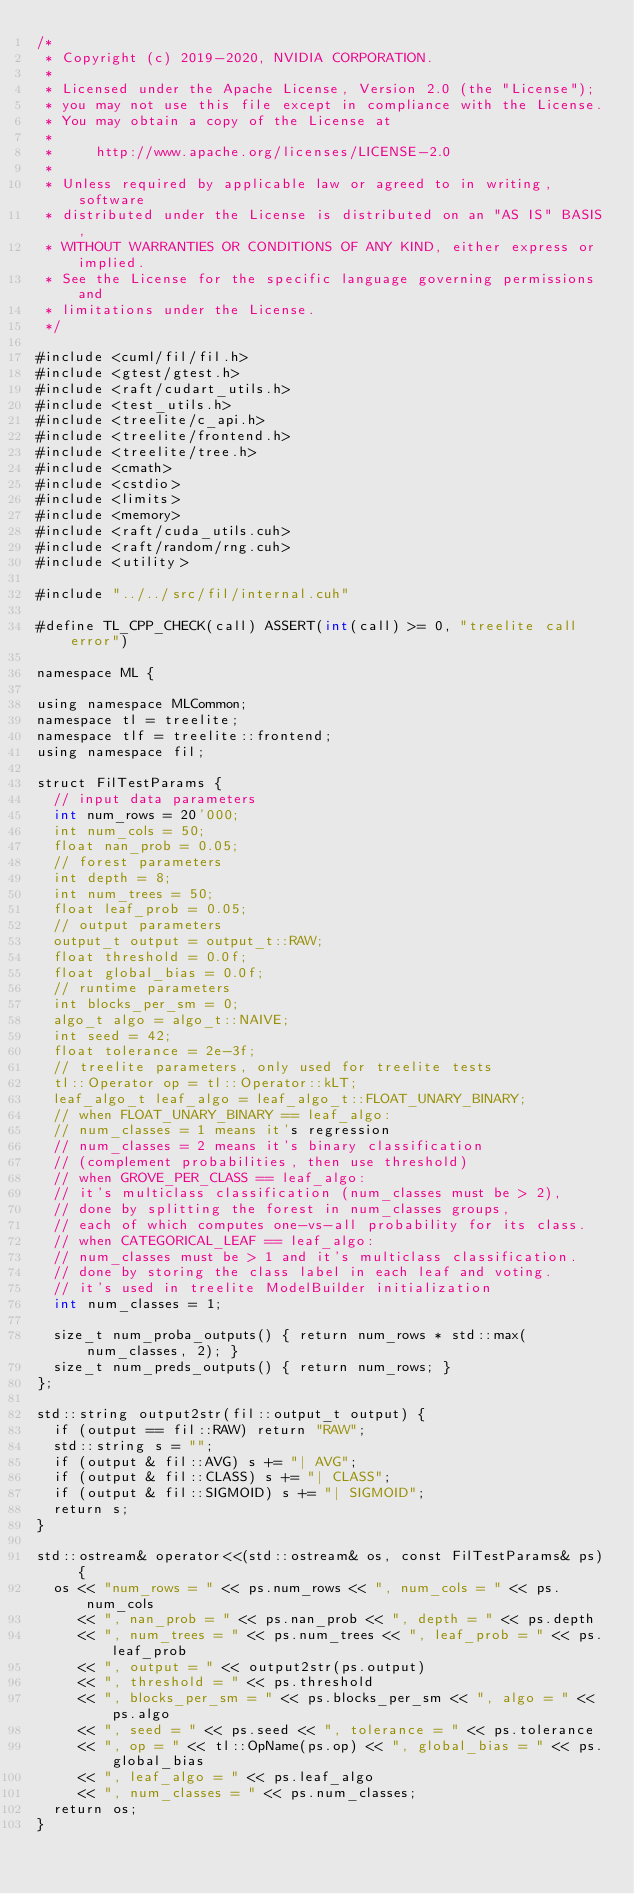<code> <loc_0><loc_0><loc_500><loc_500><_Cuda_>/*
 * Copyright (c) 2019-2020, NVIDIA CORPORATION.
 *
 * Licensed under the Apache License, Version 2.0 (the "License");
 * you may not use this file except in compliance with the License.
 * You may obtain a copy of the License at
 *
 *     http://www.apache.org/licenses/LICENSE-2.0
 *
 * Unless required by applicable law or agreed to in writing, software
 * distributed under the License is distributed on an "AS IS" BASIS,
 * WITHOUT WARRANTIES OR CONDITIONS OF ANY KIND, either express or implied.
 * See the License for the specific language governing permissions and
 * limitations under the License.
 */

#include <cuml/fil/fil.h>
#include <gtest/gtest.h>
#include <raft/cudart_utils.h>
#include <test_utils.h>
#include <treelite/c_api.h>
#include <treelite/frontend.h>
#include <treelite/tree.h>
#include <cmath>
#include <cstdio>
#include <limits>
#include <memory>
#include <raft/cuda_utils.cuh>
#include <raft/random/rng.cuh>
#include <utility>

#include "../../src/fil/internal.cuh"

#define TL_CPP_CHECK(call) ASSERT(int(call) >= 0, "treelite call error")

namespace ML {

using namespace MLCommon;
namespace tl = treelite;
namespace tlf = treelite::frontend;
using namespace fil;

struct FilTestParams {
  // input data parameters
  int num_rows = 20'000;
  int num_cols = 50;
  float nan_prob = 0.05;
  // forest parameters
  int depth = 8;
  int num_trees = 50;
  float leaf_prob = 0.05;
  // output parameters
  output_t output = output_t::RAW;
  float threshold = 0.0f;
  float global_bias = 0.0f;
  // runtime parameters
  int blocks_per_sm = 0;
  algo_t algo = algo_t::NAIVE;
  int seed = 42;
  float tolerance = 2e-3f;
  // treelite parameters, only used for treelite tests
  tl::Operator op = tl::Operator::kLT;
  leaf_algo_t leaf_algo = leaf_algo_t::FLOAT_UNARY_BINARY;
  // when FLOAT_UNARY_BINARY == leaf_algo:
  // num_classes = 1 means it's regression
  // num_classes = 2 means it's binary classification
  // (complement probabilities, then use threshold)
  // when GROVE_PER_CLASS == leaf_algo:
  // it's multiclass classification (num_classes must be > 2),
  // done by splitting the forest in num_classes groups,
  // each of which computes one-vs-all probability for its class.
  // when CATEGORICAL_LEAF == leaf_algo:
  // num_classes must be > 1 and it's multiclass classification.
  // done by storing the class label in each leaf and voting.
  // it's used in treelite ModelBuilder initialization
  int num_classes = 1;

  size_t num_proba_outputs() { return num_rows * std::max(num_classes, 2); }
  size_t num_preds_outputs() { return num_rows; }
};

std::string output2str(fil::output_t output) {
  if (output == fil::RAW) return "RAW";
  std::string s = "";
  if (output & fil::AVG) s += "| AVG";
  if (output & fil::CLASS) s += "| CLASS";
  if (output & fil::SIGMOID) s += "| SIGMOID";
  return s;
}

std::ostream& operator<<(std::ostream& os, const FilTestParams& ps) {
  os << "num_rows = " << ps.num_rows << ", num_cols = " << ps.num_cols
     << ", nan_prob = " << ps.nan_prob << ", depth = " << ps.depth
     << ", num_trees = " << ps.num_trees << ", leaf_prob = " << ps.leaf_prob
     << ", output = " << output2str(ps.output)
     << ", threshold = " << ps.threshold
     << ", blocks_per_sm = " << ps.blocks_per_sm << ", algo = " << ps.algo
     << ", seed = " << ps.seed << ", tolerance = " << ps.tolerance
     << ", op = " << tl::OpName(ps.op) << ", global_bias = " << ps.global_bias
     << ", leaf_algo = " << ps.leaf_algo
     << ", num_classes = " << ps.num_classes;
  return os;
}
</code> 